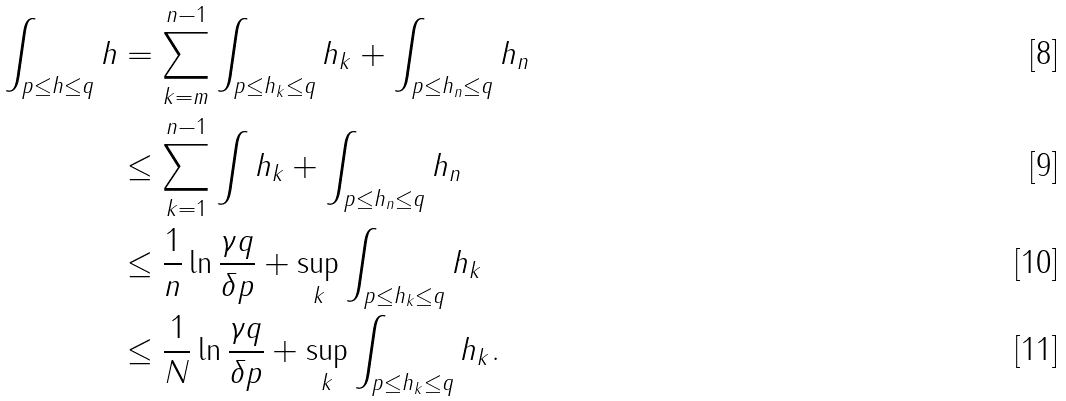<formula> <loc_0><loc_0><loc_500><loc_500>\int _ { p \leq h \leq q } h & = \sum ^ { n - 1 } _ { k = m } \int _ { p \leq h _ { k } \leq q } h _ { k } + \int _ { p \leq h _ { n } \leq q } h _ { n } \\ & \leq \sum ^ { n - 1 } _ { k = 1 } \int h _ { k } + \int _ { p \leq h _ { n } \leq q } h _ { n } \\ & \leq \frac { 1 } { n } \ln \frac { \gamma q } { \delta p } + \sup _ { k } \int _ { p \leq h _ { k } \leq q } h _ { k } \\ & \leq \frac { 1 } { N } \ln \frac { \gamma q } { \delta p } + \sup _ { k } \int _ { p \leq h _ { k } \leq q } h _ { k } .</formula> 